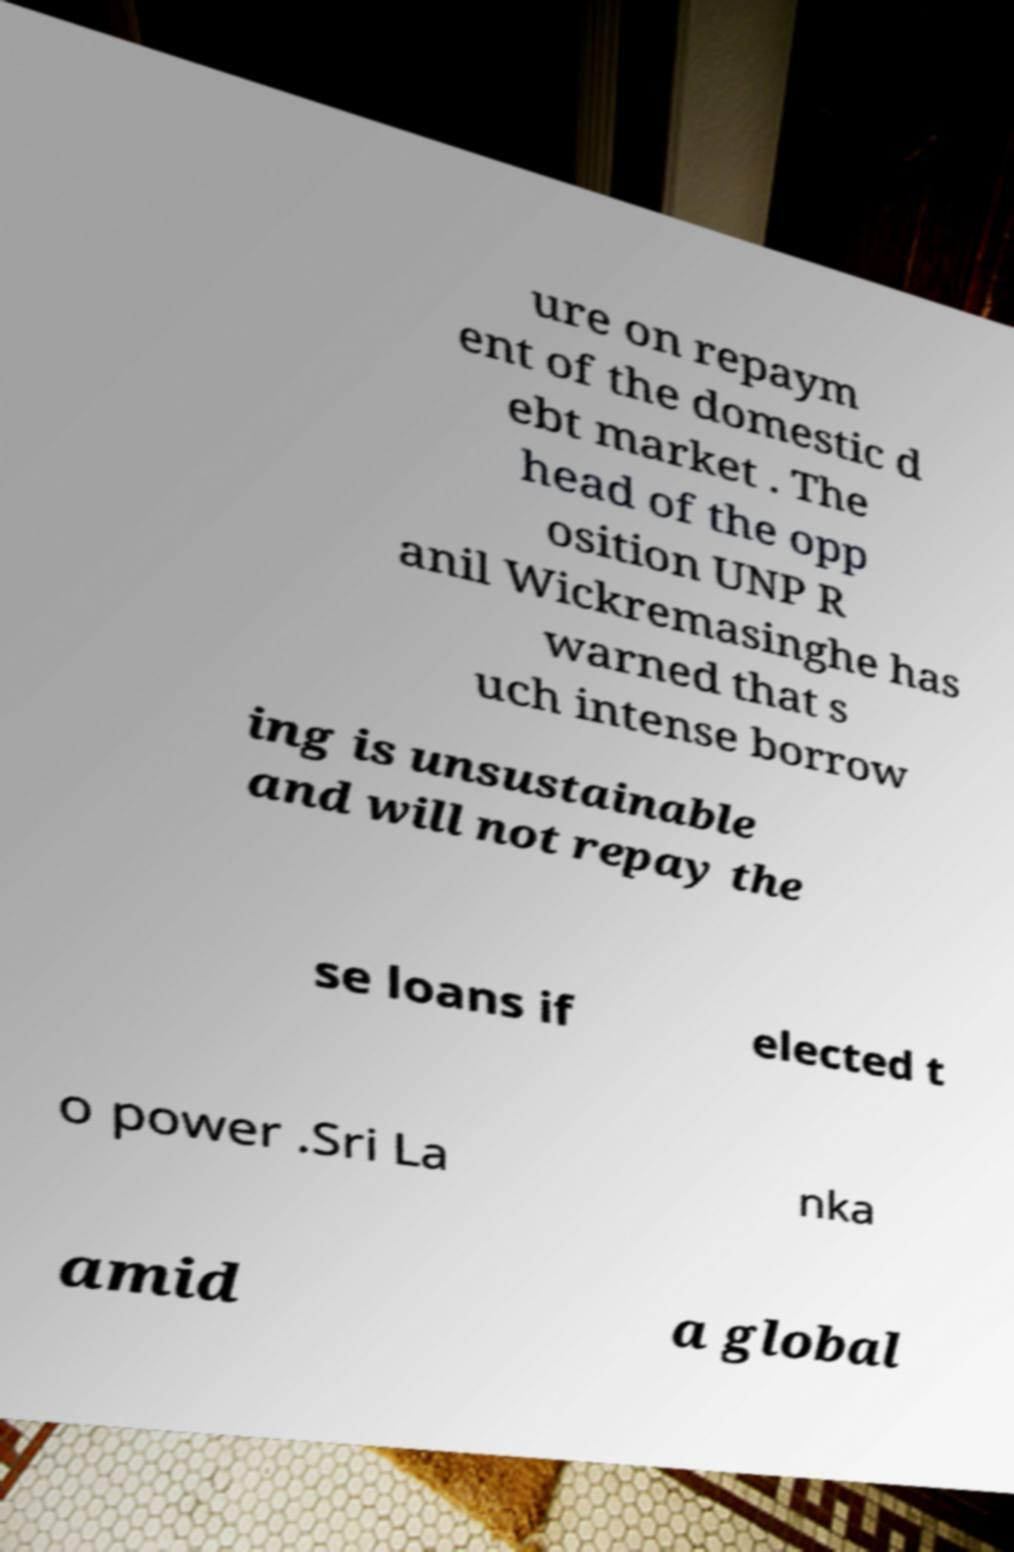Can you read and provide the text displayed in the image?This photo seems to have some interesting text. Can you extract and type it out for me? ure on repaym ent of the domestic d ebt market . The head of the opp osition UNP R anil Wickremasinghe has warned that s uch intense borrow ing is unsustainable and will not repay the se loans if elected t o power .Sri La nka amid a global 